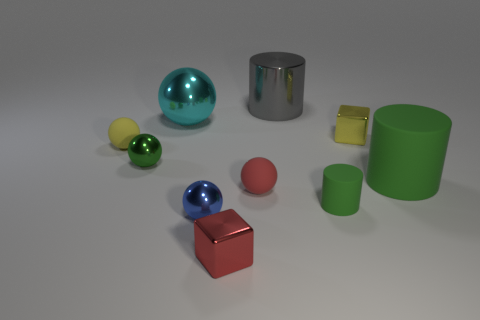Subtract all blue balls. How many balls are left? 4 Subtract all yellow balls. How many balls are left? 4 Subtract all gray spheres. Subtract all red cylinders. How many spheres are left? 5 Subtract all cylinders. How many objects are left? 7 Add 2 green metal objects. How many green metal objects are left? 3 Add 1 large green matte objects. How many large green matte objects exist? 2 Subtract 1 red spheres. How many objects are left? 9 Subtract all small red metal blocks. Subtract all red balls. How many objects are left? 8 